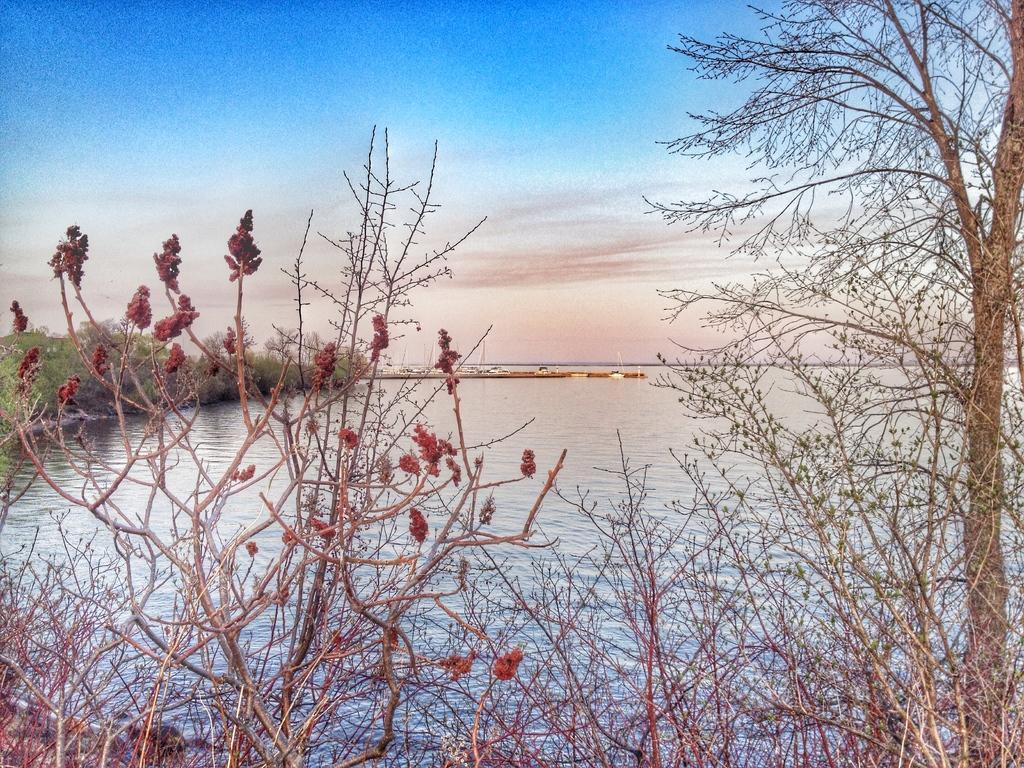How would you summarize this image in a sentence or two? In the center of the image there is a river and we can see trees. In the background there is sky. 